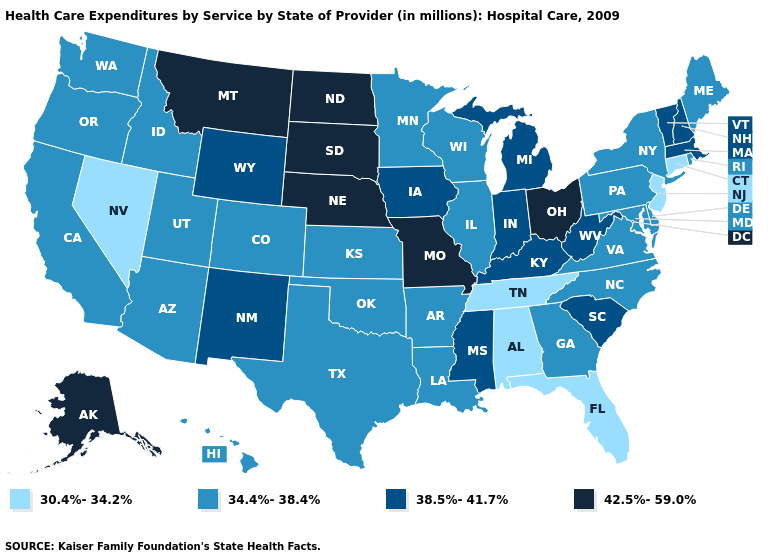Does the first symbol in the legend represent the smallest category?
Quick response, please. Yes. What is the highest value in the USA?
Keep it brief. 42.5%-59.0%. How many symbols are there in the legend?
Concise answer only. 4. Among the states that border Oregon , which have the lowest value?
Short answer required. Nevada. What is the value of New Hampshire?
Be succinct. 38.5%-41.7%. Does Alabama have the same value as Florida?
Answer briefly. Yes. Name the states that have a value in the range 38.5%-41.7%?
Concise answer only. Indiana, Iowa, Kentucky, Massachusetts, Michigan, Mississippi, New Hampshire, New Mexico, South Carolina, Vermont, West Virginia, Wyoming. Does Nevada have the lowest value in the USA?
Answer briefly. Yes. Name the states that have a value in the range 30.4%-34.2%?
Short answer required. Alabama, Connecticut, Florida, Nevada, New Jersey, Tennessee. What is the value of Illinois?
Write a very short answer. 34.4%-38.4%. Does Missouri have a higher value than New Hampshire?
Give a very brief answer. Yes. What is the lowest value in states that border Wisconsin?
Answer briefly. 34.4%-38.4%. Name the states that have a value in the range 42.5%-59.0%?
Short answer required. Alaska, Missouri, Montana, Nebraska, North Dakota, Ohio, South Dakota. Name the states that have a value in the range 34.4%-38.4%?
Answer briefly. Arizona, Arkansas, California, Colorado, Delaware, Georgia, Hawaii, Idaho, Illinois, Kansas, Louisiana, Maine, Maryland, Minnesota, New York, North Carolina, Oklahoma, Oregon, Pennsylvania, Rhode Island, Texas, Utah, Virginia, Washington, Wisconsin. Does Washington have the highest value in the USA?
Answer briefly. No. 